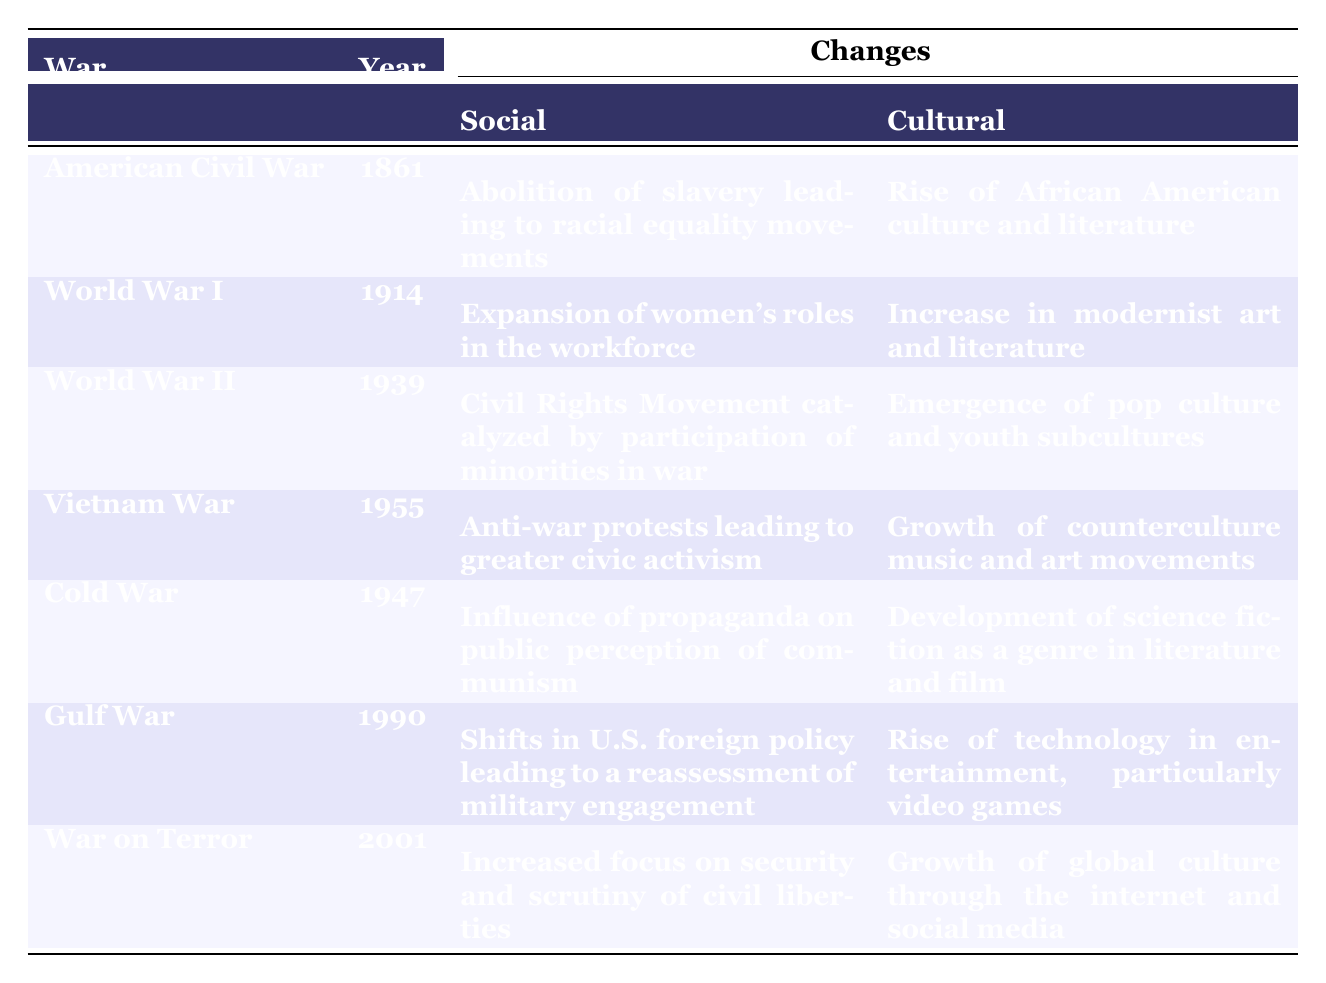What social change occurred due to the American Civil War? The table lists "Abolition of slavery leading to racial equality movements" under the social change column for the American Civil War, which occurred in 1861.
Answer: Abolition of slavery leading to racial equality movements Which war led to the increase in modernist art and literature? According to the table, World War I, which started in 1914, is associated with "Increase in modernist art and literature" in the cultural change column.
Answer: World War I True or False: The Gulf War caused a shift in U.S. foreign policy and the rise of video games. The table states that the Gulf War in 1990 resulted in "Shifts in U.S. foreign policy leading to a reassessment of military engagement" and a "Rise of technology in entertainment, particularly video games," confirming the statement is true.
Answer: True What is the primary cultural change noted as a result of the Vietnam War? The table indicates that the Vietnam War, starting in 1955, led to the "Growth of counterculture music and art movements" in the cultural change column.
Answer: Growth of counterculture music and art movements Which two wars are associated with the emergence of new cultural movements in the United States? The table shows that World War II led to the "Emergence of pop culture and youth subcultures," and the Vietnam War caused the "Growth of counterculture music and art movements," meaning both wars are linked to new cultural movements.
Answer: World War II and Vietnam War How many wars are associated with the development of science fiction as a genre? The table lists the Cold War (1947) as having a cultural change related to the "Development of science fiction as a genre in literature and film." Thus, there is only one war associated with this particular cultural change.
Answer: 1 What were the social changes resulting from the War on Terror? The table notes that the War on Terror, starting in 2001, led to "Increased focus on security and scrutiny of civil liberties" under the social change column.
Answer: Increased focus on security and scrutiny of civil liberties Which war had the earliest impact on cultural changes, and what was that change? The table shows that the American Civil War (1861) led to the "Rise of African American culture and literature," making it the earliest war impacting cultural changes.
Answer: American Civil War; Rise of African American culture and literature In which year did the Civil Rights Movement begin as a result of participation in a major war? The table indicates that World War II, which started in 1939, catalyzed the Civil Rights Movement due to the involvement of minorities in the war.
Answer: 1939 